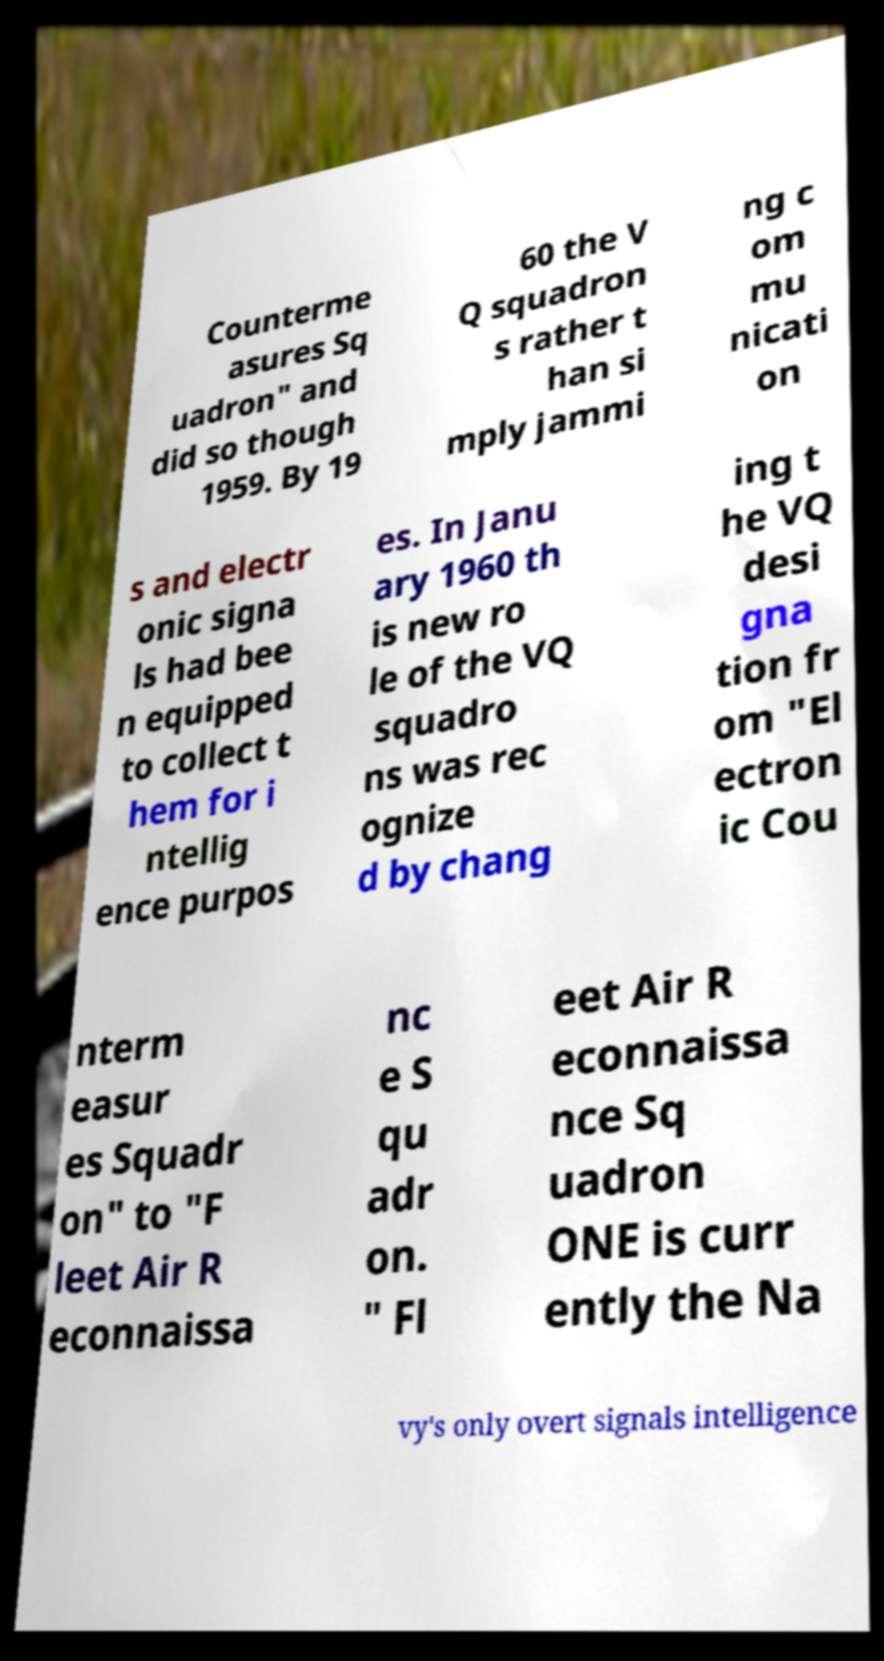Can you accurately transcribe the text from the provided image for me? Counterme asures Sq uadron" and did so though 1959. By 19 60 the V Q squadron s rather t han si mply jammi ng c om mu nicati on s and electr onic signa ls had bee n equipped to collect t hem for i ntellig ence purpos es. In Janu ary 1960 th is new ro le of the VQ squadro ns was rec ognize d by chang ing t he VQ desi gna tion fr om "El ectron ic Cou nterm easur es Squadr on" to "F leet Air R econnaissa nc e S qu adr on. " Fl eet Air R econnaissa nce Sq uadron ONE is curr ently the Na vy's only overt signals intelligence 